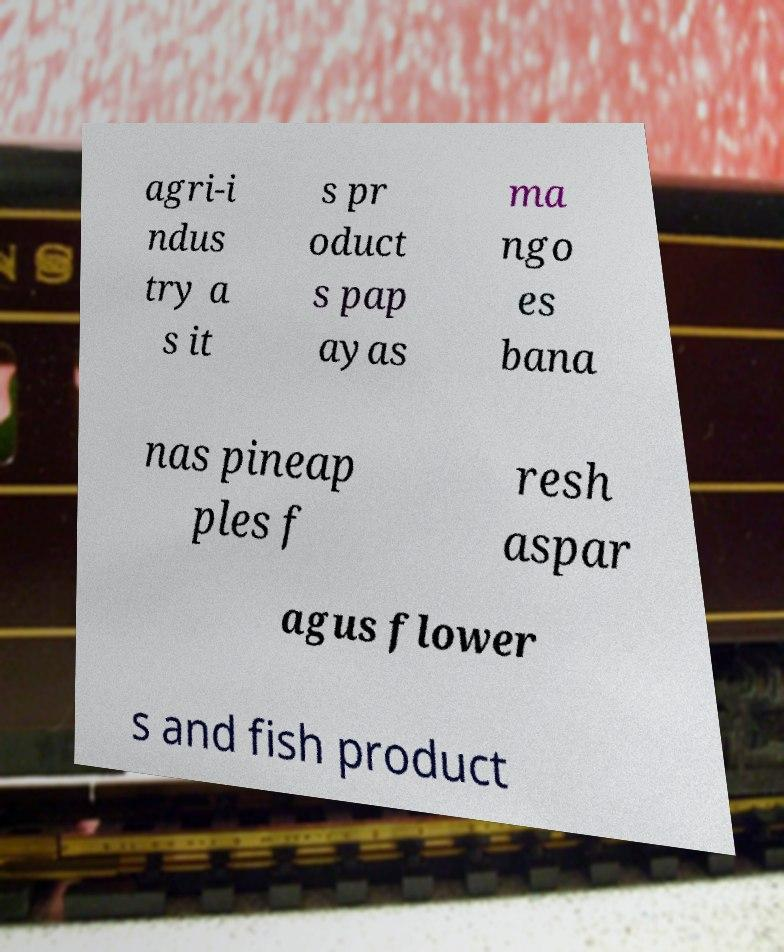Please identify and transcribe the text found in this image. agri-i ndus try a s it s pr oduct s pap ayas ma ngo es bana nas pineap ples f resh aspar agus flower s and fish product 